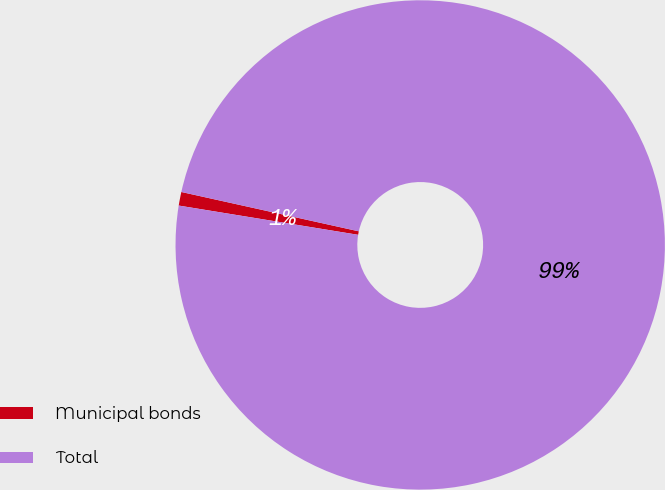Convert chart. <chart><loc_0><loc_0><loc_500><loc_500><pie_chart><fcel>Municipal bonds<fcel>Total<nl><fcel>0.9%<fcel>99.1%<nl></chart> 